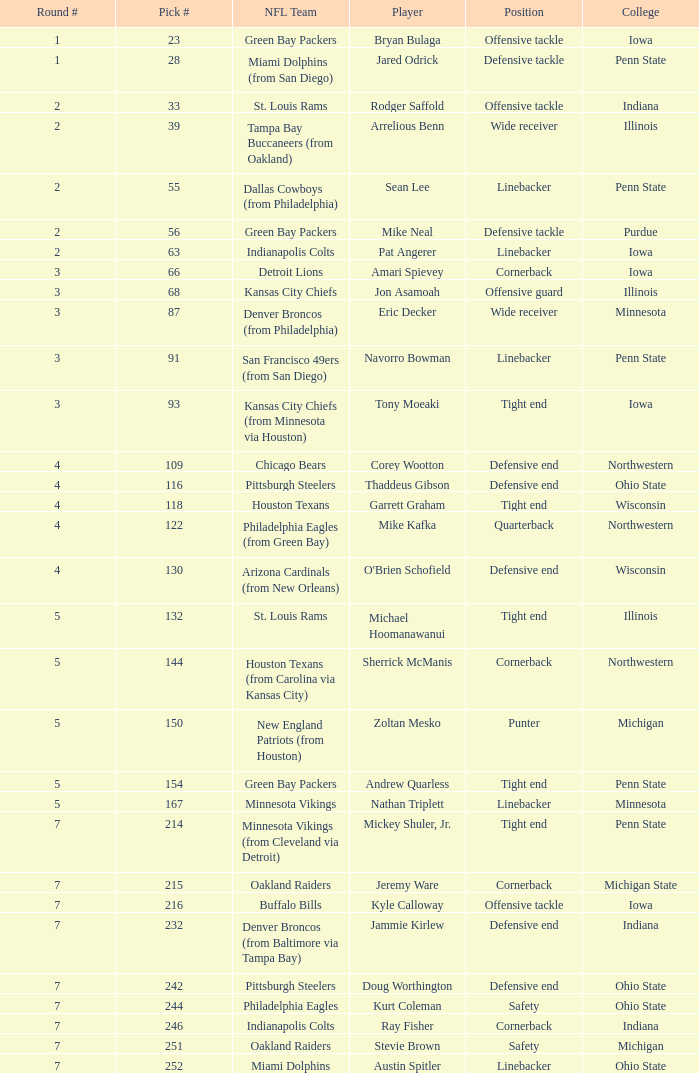Give me the full table as a dictionary. {'header': ['Round #', 'Pick #', 'NFL Team', 'Player', 'Position', 'College'], 'rows': [['1', '23', 'Green Bay Packers', 'Bryan Bulaga', 'Offensive tackle', 'Iowa'], ['1', '28', 'Miami Dolphins (from San Diego)', 'Jared Odrick', 'Defensive tackle', 'Penn State'], ['2', '33', 'St. Louis Rams', 'Rodger Saffold', 'Offensive tackle', 'Indiana'], ['2', '39', 'Tampa Bay Buccaneers (from Oakland)', 'Arrelious Benn', 'Wide receiver', 'Illinois'], ['2', '55', 'Dallas Cowboys (from Philadelphia)', 'Sean Lee', 'Linebacker', 'Penn State'], ['2', '56', 'Green Bay Packers', 'Mike Neal', 'Defensive tackle', 'Purdue'], ['2', '63', 'Indianapolis Colts', 'Pat Angerer', 'Linebacker', 'Iowa'], ['3', '66', 'Detroit Lions', 'Amari Spievey', 'Cornerback', 'Iowa'], ['3', '68', 'Kansas City Chiefs', 'Jon Asamoah', 'Offensive guard', 'Illinois'], ['3', '87', 'Denver Broncos (from Philadelphia)', 'Eric Decker', 'Wide receiver', 'Minnesota'], ['3', '91', 'San Francisco 49ers (from San Diego)', 'Navorro Bowman', 'Linebacker', 'Penn State'], ['3', '93', 'Kansas City Chiefs (from Minnesota via Houston)', 'Tony Moeaki', 'Tight end', 'Iowa'], ['4', '109', 'Chicago Bears', 'Corey Wootton', 'Defensive end', 'Northwestern'], ['4', '116', 'Pittsburgh Steelers', 'Thaddeus Gibson', 'Defensive end', 'Ohio State'], ['4', '118', 'Houston Texans', 'Garrett Graham', 'Tight end', 'Wisconsin'], ['4', '122', 'Philadelphia Eagles (from Green Bay)', 'Mike Kafka', 'Quarterback', 'Northwestern'], ['4', '130', 'Arizona Cardinals (from New Orleans)', "O'Brien Schofield", 'Defensive end', 'Wisconsin'], ['5', '132', 'St. Louis Rams', 'Michael Hoomanawanui', 'Tight end', 'Illinois'], ['5', '144', 'Houston Texans (from Carolina via Kansas City)', 'Sherrick McManis', 'Cornerback', 'Northwestern'], ['5', '150', 'New England Patriots (from Houston)', 'Zoltan Mesko', 'Punter', 'Michigan'], ['5', '154', 'Green Bay Packers', 'Andrew Quarless', 'Tight end', 'Penn State'], ['5', '167', 'Minnesota Vikings', 'Nathan Triplett', 'Linebacker', 'Minnesota'], ['7', '214', 'Minnesota Vikings (from Cleveland via Detroit)', 'Mickey Shuler, Jr.', 'Tight end', 'Penn State'], ['7', '215', 'Oakland Raiders', 'Jeremy Ware', 'Cornerback', 'Michigan State'], ['7', '216', 'Buffalo Bills', 'Kyle Calloway', 'Offensive tackle', 'Iowa'], ['7', '232', 'Denver Broncos (from Baltimore via Tampa Bay)', 'Jammie Kirlew', 'Defensive end', 'Indiana'], ['7', '242', 'Pittsburgh Steelers', 'Doug Worthington', 'Defensive end', 'Ohio State'], ['7', '244', 'Philadelphia Eagles', 'Kurt Coleman', 'Safety', 'Ohio State'], ['7', '246', 'Indianapolis Colts', 'Ray Fisher', 'Cornerback', 'Indiana'], ['7', '251', 'Oakland Raiders', 'Stevie Brown', 'Safety', 'Michigan'], ['7', '252', 'Miami Dolphins', 'Austin Spitler', 'Linebacker', 'Ohio State']]} What NFL team was the player with pick number 28 drafted to? Miami Dolphins (from San Diego). 